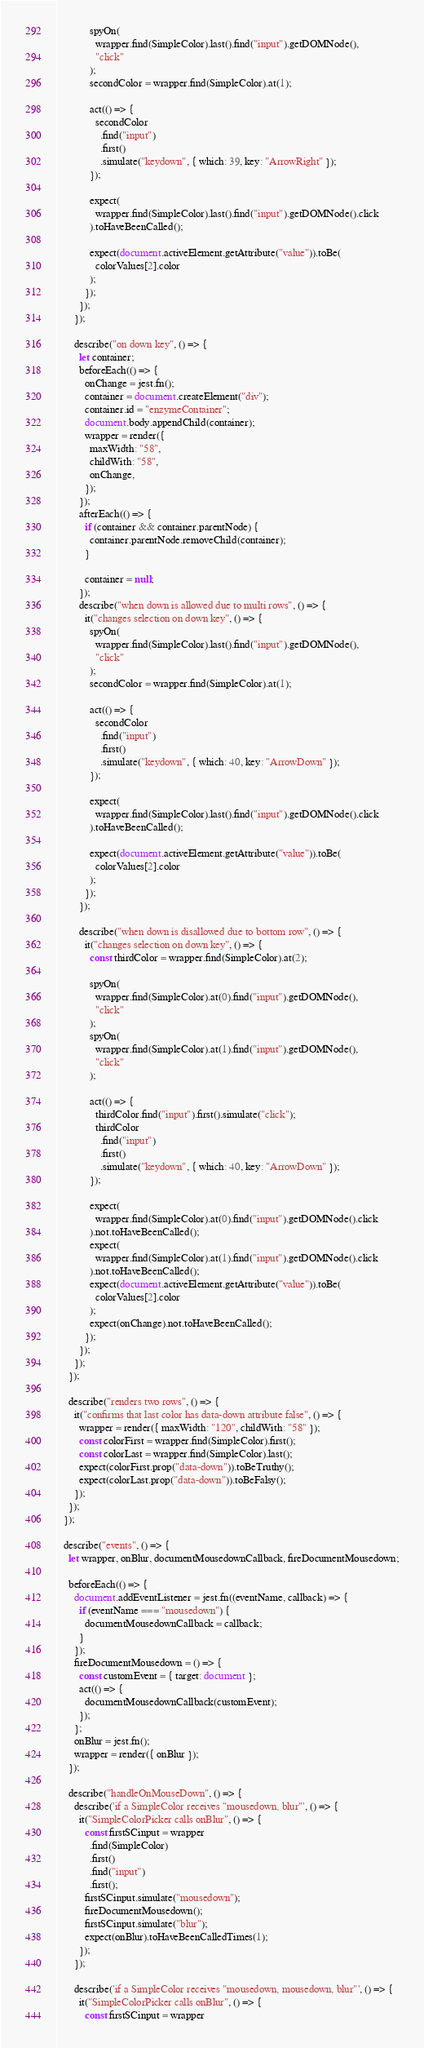Convert code to text. <code><loc_0><loc_0><loc_500><loc_500><_JavaScript_>            spyOn(
              wrapper.find(SimpleColor).last().find("input").getDOMNode(),
              "click"
            );
            secondColor = wrapper.find(SimpleColor).at(1);

            act(() => {
              secondColor
                .find("input")
                .first()
                .simulate("keydown", { which: 39, key: "ArrowRight" });
            });

            expect(
              wrapper.find(SimpleColor).last().find("input").getDOMNode().click
            ).toHaveBeenCalled();

            expect(document.activeElement.getAttribute("value")).toBe(
              colorValues[2].color
            );
          });
        });
      });

      describe("on down key", () => {
        let container;
        beforeEach(() => {
          onChange = jest.fn();
          container = document.createElement("div");
          container.id = "enzymeContainer";
          document.body.appendChild(container);
          wrapper = render({
            maxWidth: "58",
            childWith: "58",
            onChange,
          });
        });
        afterEach(() => {
          if (container && container.parentNode) {
            container.parentNode.removeChild(container);
          }

          container = null;
        });
        describe("when down is allowed due to multi rows", () => {
          it("changes selection on down key", () => {
            spyOn(
              wrapper.find(SimpleColor).last().find("input").getDOMNode(),
              "click"
            );
            secondColor = wrapper.find(SimpleColor).at(1);

            act(() => {
              secondColor
                .find("input")
                .first()
                .simulate("keydown", { which: 40, key: "ArrowDown" });
            });

            expect(
              wrapper.find(SimpleColor).last().find("input").getDOMNode().click
            ).toHaveBeenCalled();

            expect(document.activeElement.getAttribute("value")).toBe(
              colorValues[2].color
            );
          });
        });

        describe("when down is disallowed due to bottom row", () => {
          it("changes selection on down key", () => {
            const thirdColor = wrapper.find(SimpleColor).at(2);

            spyOn(
              wrapper.find(SimpleColor).at(0).find("input").getDOMNode(),
              "click"
            );
            spyOn(
              wrapper.find(SimpleColor).at(1).find("input").getDOMNode(),
              "click"
            );

            act(() => {
              thirdColor.find("input").first().simulate("click");
              thirdColor
                .find("input")
                .first()
                .simulate("keydown", { which: 40, key: "ArrowDown" });
            });

            expect(
              wrapper.find(SimpleColor).at(0).find("input").getDOMNode().click
            ).not.toHaveBeenCalled();
            expect(
              wrapper.find(SimpleColor).at(1).find("input").getDOMNode().click
            ).not.toHaveBeenCalled();
            expect(document.activeElement.getAttribute("value")).toBe(
              colorValues[2].color
            );
            expect(onChange).not.toHaveBeenCalled();
          });
        });
      });
    });

    describe("renders two rows", () => {
      it("confirms that last color has data-down attribute false", () => {
        wrapper = render({ maxWidth: "120", childWith: "58" });
        const colorFirst = wrapper.find(SimpleColor).first();
        const colorLast = wrapper.find(SimpleColor).last();
        expect(colorFirst.prop("data-down")).toBeTruthy();
        expect(colorLast.prop("data-down")).toBeFalsy();
      });
    });
  });

  describe("events", () => {
    let wrapper, onBlur, documentMousedownCallback, fireDocumentMousedown;

    beforeEach(() => {
      document.addEventListener = jest.fn((eventName, callback) => {
        if (eventName === "mousedown") {
          documentMousedownCallback = callback;
        }
      });
      fireDocumentMousedown = () => {
        const customEvent = { target: document };
        act(() => {
          documentMousedownCallback(customEvent);
        });
      };
      onBlur = jest.fn();
      wrapper = render({ onBlur });
    });

    describe("handleOnMouseDown", () => {
      describe('if a SimpleColor receives "mousedown, blur"', () => {
        it("SimpleColorPicker calls onBlur", () => {
          const firstSCinput = wrapper
            .find(SimpleColor)
            .first()
            .find("input")
            .first();
          firstSCinput.simulate("mousedown");
          fireDocumentMousedown();
          firstSCinput.simulate("blur");
          expect(onBlur).toHaveBeenCalledTimes(1);
        });
      });

      describe('if a SimpleColor receives "mousedown, mousedown, blur"', () => {
        it("SimpleColorPicker calls onBlur", () => {
          const firstSCinput = wrapper</code> 